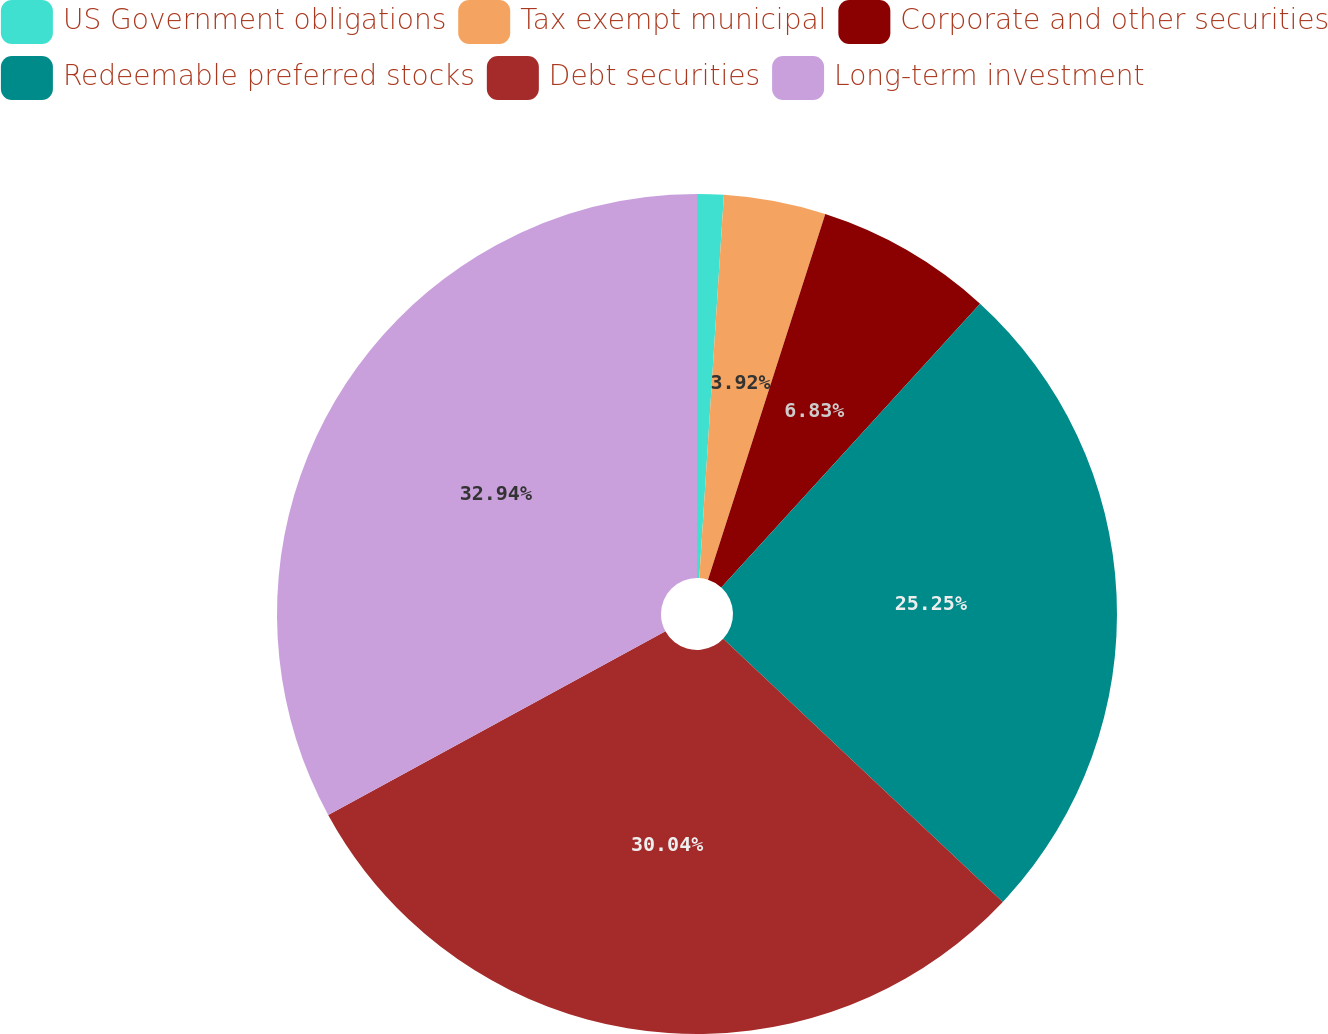Convert chart. <chart><loc_0><loc_0><loc_500><loc_500><pie_chart><fcel>US Government obligations<fcel>Tax exempt municipal<fcel>Corporate and other securities<fcel>Redeemable preferred stocks<fcel>Debt securities<fcel>Long-term investment<nl><fcel>1.02%<fcel>3.92%<fcel>6.83%<fcel>25.25%<fcel>30.04%<fcel>32.94%<nl></chart> 